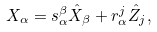<formula> <loc_0><loc_0><loc_500><loc_500>X _ { \alpha } = s _ { \alpha } ^ { \beta } \hat { X } _ { \beta } + r _ { \alpha } ^ { j } \hat { Z } _ { j } ,</formula> 